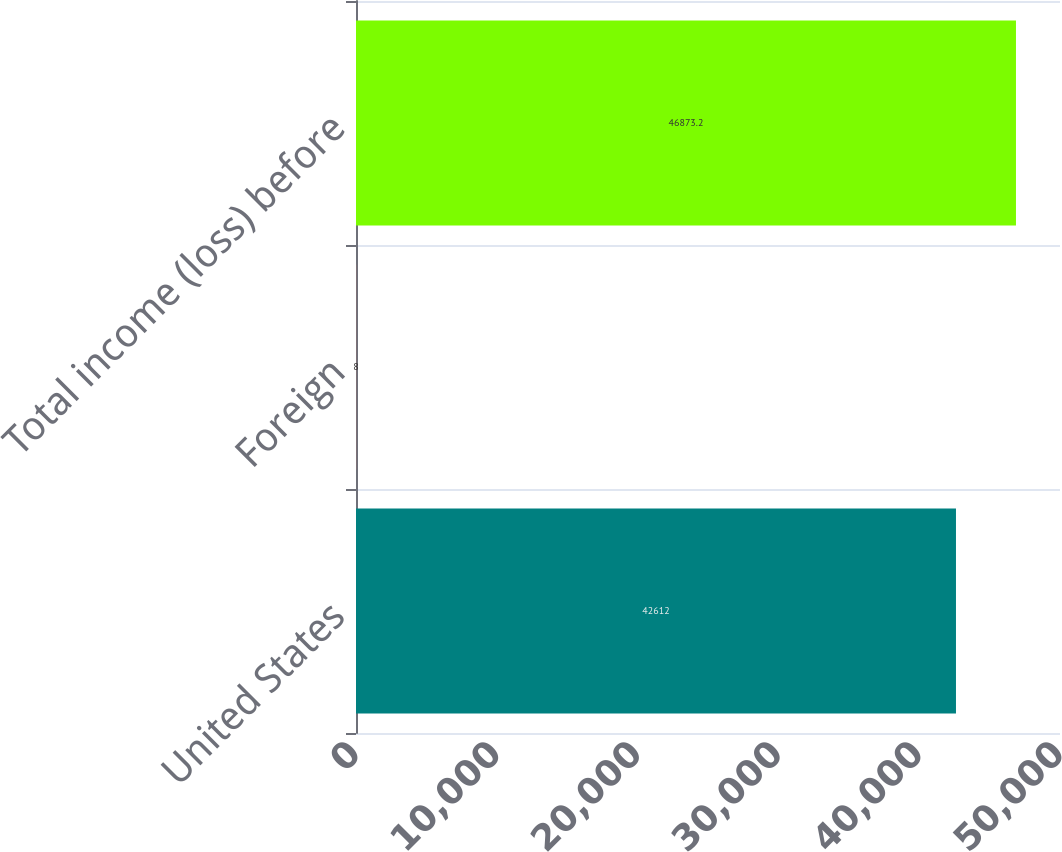<chart> <loc_0><loc_0><loc_500><loc_500><bar_chart><fcel>United States<fcel>Foreign<fcel>Total income (loss) before<nl><fcel>42612<fcel>8<fcel>46873.2<nl></chart> 